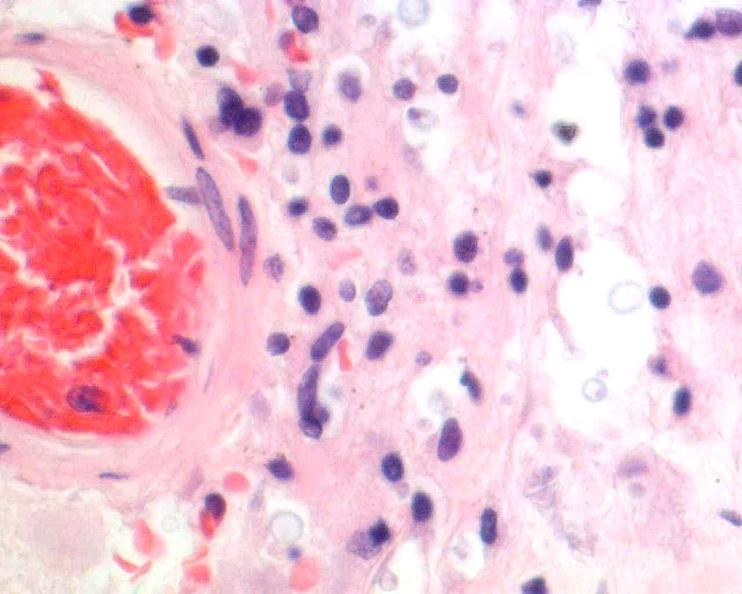does this image show brain, cryptococcal meningitis, he?
Answer the question using a single word or phrase. Yes 